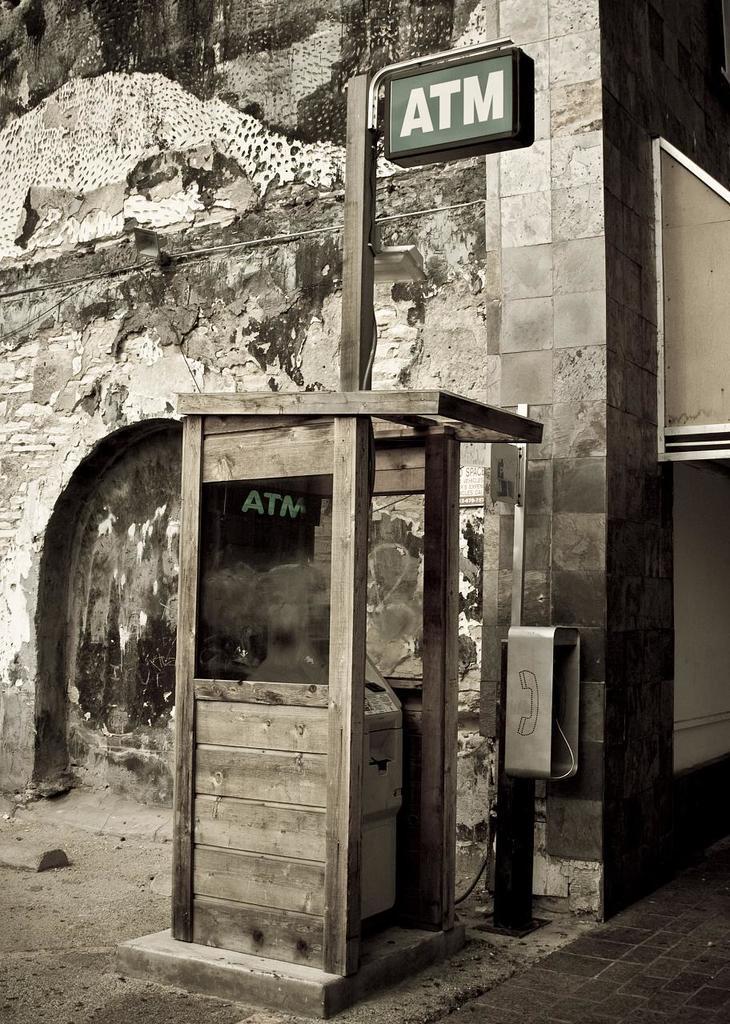Please provide a concise description of this image. In this picture we can see a machine, booth, wooden pole, name board, telephone, wall, floor and some objects. 